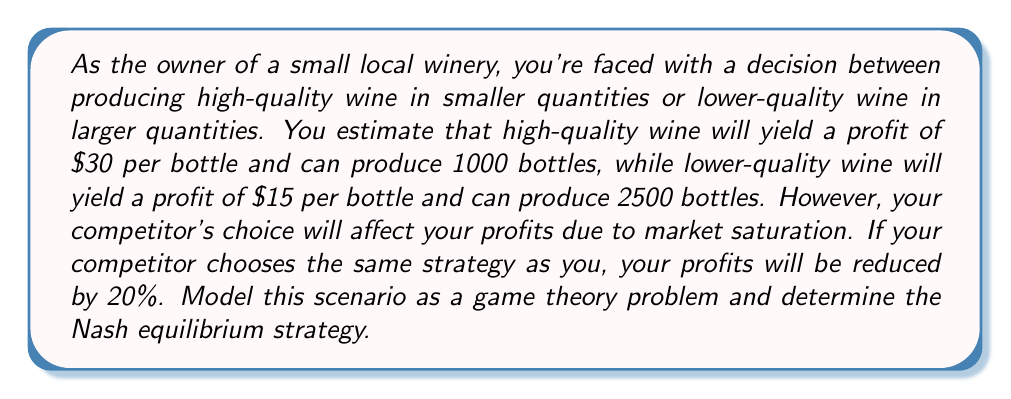Show me your answer to this math problem. Let's approach this problem step-by-step using game theory principles:

1) First, let's define the players and strategies:
   - Players: You and your competitor
   - Strategies: High-quality (H) or Low-quality (L)

2) Now, let's calculate the payoffs for each scenario:

   For you:
   - H strategy: $30 * 1000 = $30,000
   - L strategy: $15 * 2500 = $37,500

   If the competitor chooses the same strategy, profits are reduced by 20%:
   - H vs H: $30,000 * 0.8 = $24,000
   - L vs L: $37,500 * 0.8 = $30,000

3) We can now construct the payoff matrix:

   $$
   \begin{array}{c|c|c}
    & \text{Competitor H} & \text{Competitor L} \\
   \hline
   \text{You H} & (24000, 24000) & (30000, 37500) \\
   \hline
   \text{You L} & (37500, 30000) & (30000, 30000)
   \end{array}
   $$

4) To find the Nash equilibrium, we need to identify strategies where neither player has an incentive to unilaterally change their strategy.

5) Let's analyze each player's best responses:
   - If the competitor chooses H, your best response is L ($37,500 > $24,000)
   - If the competitor chooses L, your best response is H ($30,000 > $30,000, assuming you prefer quality if profits are equal)
   - If you choose H, the competitor's best response is L ($37,500 > $24,000)
   - If you choose L, the competitor's best response is H ($30,000 > $30,000, assuming they also prefer quality if profits are equal)

6) We can see that there's no pure strategy Nash equilibrium, as there's no cell where both players are playing their best responses to each other.

7) In this case, we need to look for a mixed strategy Nash equilibrium. Let's say you choose H with probability p and L with probability (1-p).

8) For the competitor to be indifferent between H and L:

   $$24000p + 37500(1-p) = 30000p + 30000(1-p)$$

9) Solving this equation:

   $$24000p + 37500 - 37500p = 30000$$
   $$-13500p + 37500 = 30000$$
   $$-13500p = -7500$$
   $$p = \frac{5}{9} \approx 0.556$$

10) Due to the symmetry of the game, this is also the probability for your competitor.

Therefore, the mixed strategy Nash equilibrium is for both you and your competitor to choose the high-quality strategy with probability $\frac{5}{9}$ and the low-quality strategy with probability $\frac{4}{9}$.
Answer: The Nash equilibrium strategy is a mixed strategy where both you and your competitor should choose the high-quality wine production strategy with probability $\frac{5}{9}$ (approximately 0.556 or 55.6%) and the low-quality wine production strategy with probability $\frac{4}{9}$ (approximately 0.444 or 44.4%). 